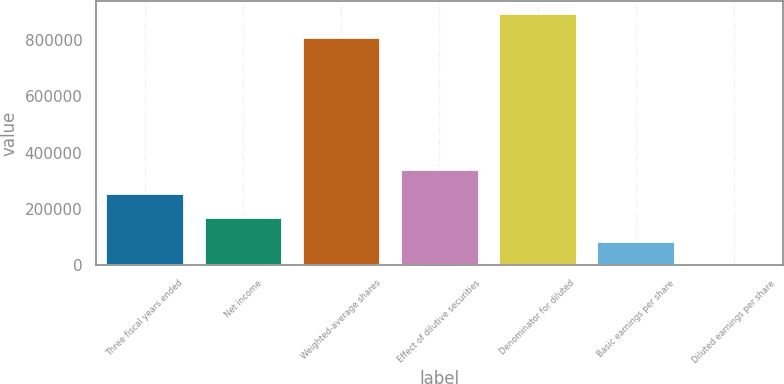Convert chart. <chart><loc_0><loc_0><loc_500><loc_500><bar_chart><fcel>Three fiscal years ended<fcel>Net income<fcel>Weighted-average shares<fcel>Effect of dilutive securities<fcel>Denominator for diluted<fcel>Basic earnings per share<fcel>Diluted earnings per share<nl><fcel>257064<fcel>171377<fcel>808439<fcel>342752<fcel>894127<fcel>85689.2<fcel>1.55<nl></chart> 